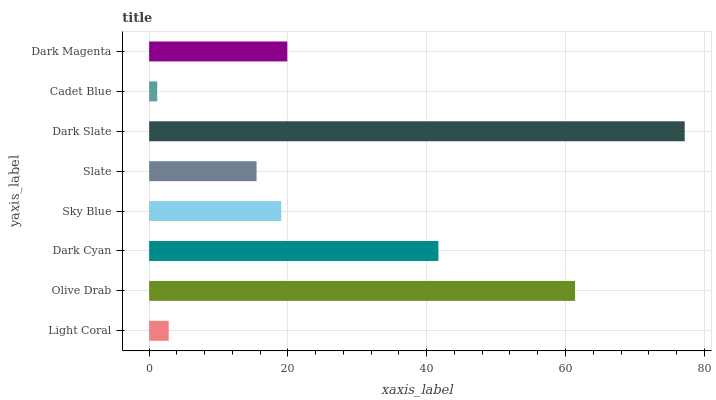Is Cadet Blue the minimum?
Answer yes or no. Yes. Is Dark Slate the maximum?
Answer yes or no. Yes. Is Olive Drab the minimum?
Answer yes or no. No. Is Olive Drab the maximum?
Answer yes or no. No. Is Olive Drab greater than Light Coral?
Answer yes or no. Yes. Is Light Coral less than Olive Drab?
Answer yes or no. Yes. Is Light Coral greater than Olive Drab?
Answer yes or no. No. Is Olive Drab less than Light Coral?
Answer yes or no. No. Is Dark Magenta the high median?
Answer yes or no. Yes. Is Sky Blue the low median?
Answer yes or no. Yes. Is Slate the high median?
Answer yes or no. No. Is Slate the low median?
Answer yes or no. No. 